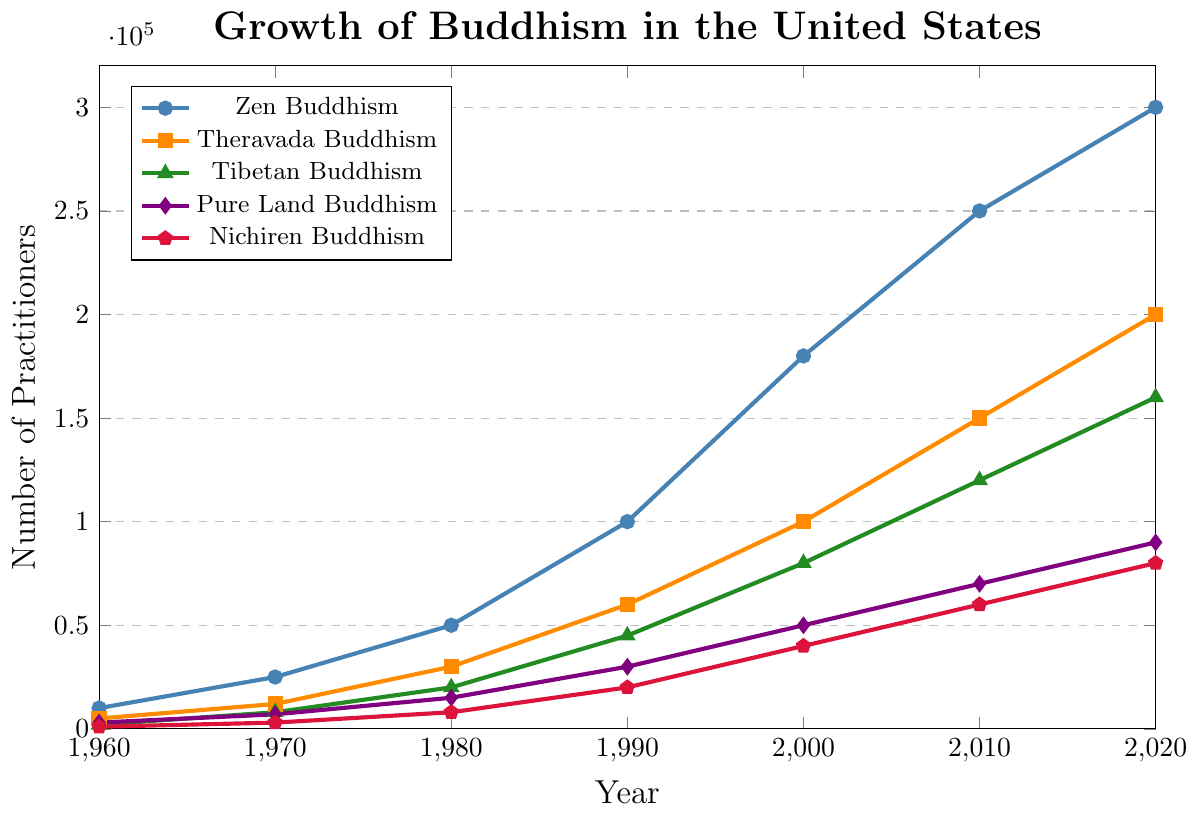Which school of Buddhism had the highest number of practitioners in 2020? Look at the points on the Y-axis for the year 2020 and compare the height of the lines. Zen Buddhism has the highest point at 300,000 practitioners.
Answer: Zen Buddhism Which school of Buddhism had the least growth from 1960 to 2020? Calculate the difference between the numbers in 2020 and 1960 for each school: Zen (300,000 - 10,000 = 290,000), Theravada (200,000 - 5,000 = 195,000), Tibetan (160,000 - 2,000 = 158,000), Pure Land (90,000 - 3,000 = 87,000), Nichiren (80,000 - 1,000 = 79,000). Nichiren Buddhism had the least growth.
Answer: Nichiren Buddhism In which decade did Tibetan Buddhism see the highest increase in practitioners? Compare the increments between each decade: 1960-1970 (8,000 - 2,000 = 6,000), 1970-1980 (20,000 - 8,000 = 12,000), 1980-1990 (45,000 - 20,000 = 25,000), 1990-2000 (80,000 - 45,000 = 35,000), 2000-2010 (120,000 - 80,000 = 40,000), 2010-2020 (160,000 - 120,000 = 40,000). The largest increase is 40,000 from 2000 to 2010 and 2010 to 2020.
Answer: 2000-2010 and 2010-2020 Which Buddhism school had the highest relative growth from 1960 to 2020? To find relative growth, calculate the growth relative to the 1960 value. Zen (2900%), Theravada (3900%), Tibetan (7900%), Pure Land (2900%), Nichiren (7900%). Tibetan and Nichiren Buddhism had the highest relative growth (7900%).
Answer: Tibetan Buddhism and Nichiren Buddhism What is the total number of practitioners across all schools in 1980? Add the number of practitioners for all schools in 1980: Zen (50,000) + Theravada (30,000) + Tibetan (20,000) + Pure Land (15,000) + Nichiren (8,000) = 123,000.
Answer: 123,000 How many more Zen practitioners were there compared to Theravada practitioners in 2000? Subtract the number of Theravada practitioners from Zen practitioners in 2000: 180,000 - 100,000 = 80,000.
Answer: 80,000 Which school showed an equal number of practitioners in any two decades? Compare the numbers across decades for each school. No school shows an equal number in any two decades.
Answer: None In which decade did Pure Land Buddhism see the smallest growth, and by how much? Calculate the growth for each decade: 1960-1970 (7,000 - 3,000 = 4,000), 1970-1980 (15,000 - 7,000 = 8,000), 1980-1990 (30,000 - 15,000 = 15,000), 1990-2000 (50,000 - 30,000 = 20,000), 2000-2010 (70,000 - 50,000 = 20,000), 2010-2020 (90,000 - 70,000 = 20,000). The smallest growth is 4,000 from 1960 to 1970.
Answer: 1960-1970, 4,000 Which school of Buddhism had the highest practitioners in 2010 relative to its numbers in 1960? Calculate the ratio for each school: Zen (25), Theravada (30), Tibetan (60), Pure Land (23.33), Nichiren (60). Tibetan and Nichiren Buddhism have the highest relative increase (60).
Answer: Tibetan Buddhism and Nichiren Buddhism 